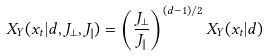<formula> <loc_0><loc_0><loc_500><loc_500>X _ { \Upsilon } ( x _ { t } | d , J _ { \perp } , J _ { \| } ) = \left ( \frac { J _ { \perp } } { J _ { \| } } \right ) ^ { ( d - 1 ) / 2 } X _ { \Upsilon } ( x _ { t } | d )</formula> 